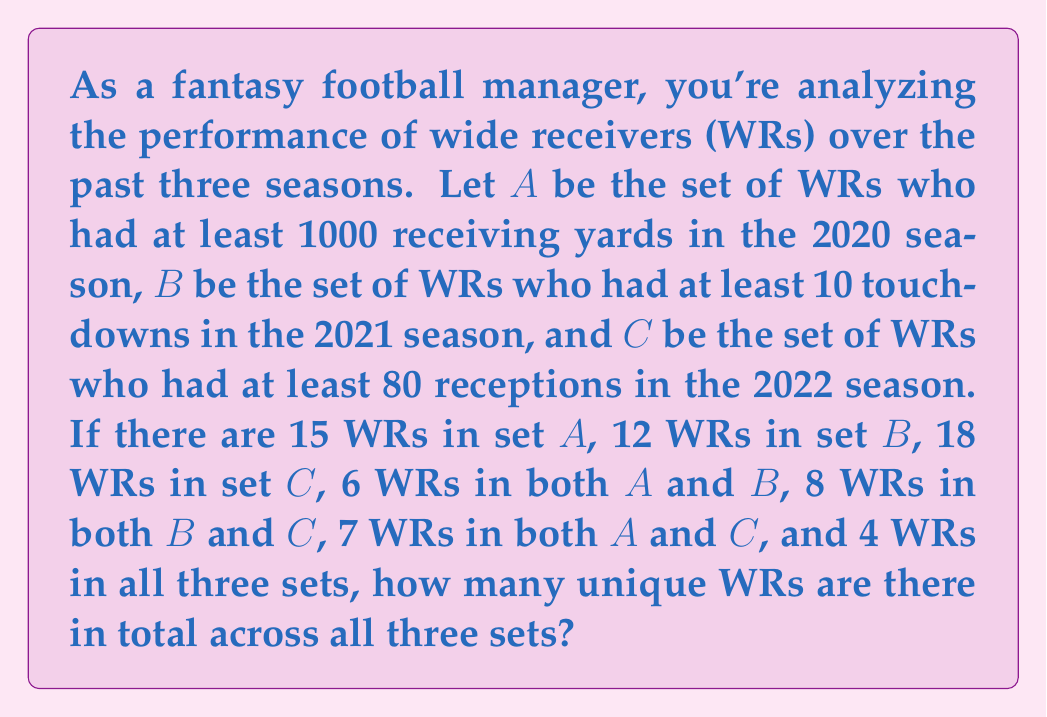What is the answer to this math problem? To solve this problem, we'll use the principle of inclusion-exclusion for three sets. Let's break it down step-by-step:

1) First, let's recall the formula for the number of elements in the union of three sets:

   $$|A \cup B \cup C| = |A| + |B| + |C| - |A \cap B| - |B \cap C| - |A \cap C| + |A \cap B \cap C|$$

2) We're given the following information:
   - $|A| = 15$
   - $|B| = 12$
   - $|C| = 18$
   - $|A \cap B| = 6$
   - $|B \cap C| = 8$
   - $|A \cap C| = 7$
   - $|A \cap B \cap C| = 4$

3) Now, let's substitute these values into our formula:

   $$|A \cup B \cup C| = 15 + 12 + 18 - 6 - 8 - 7 + 4$$

4) Let's calculate:
   
   $$|A \cup B \cup C| = 45 - 21 + 4 = 28$$

Therefore, there are 28 unique wide receivers across all three sets.
Answer: 28 unique wide receivers 